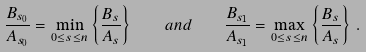Convert formula to latex. <formula><loc_0><loc_0><loc_500><loc_500>\frac { B _ { s _ { 0 } } } { A _ { s _ { 0 } } } = \min _ { 0 \leq s \leq n } \left \{ \frac { B _ { s } } { A _ { s } } \right \} \quad a n d \quad \frac { B _ { s _ { 1 } } } { A _ { s _ { 1 } } } = \max _ { 0 \leq s \leq n } \left \{ \frac { B _ { s } } { A _ { s } } \right \} \, .</formula> 